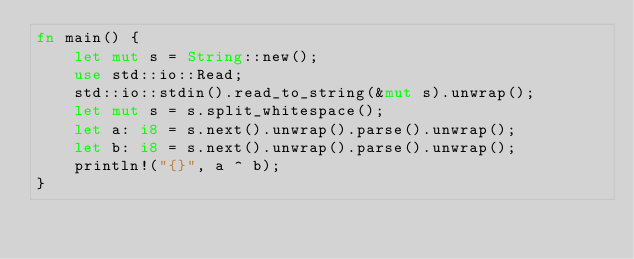<code> <loc_0><loc_0><loc_500><loc_500><_Rust_>fn main() {
	let mut s = String::new();
	use std::io::Read;
	std::io::stdin().read_to_string(&mut s).unwrap();
	let mut s = s.split_whitespace();
	let a: i8 = s.next().unwrap().parse().unwrap();
	let b: i8 = s.next().unwrap().parse().unwrap();
	println!("{}", a ^ b);
}
</code> 